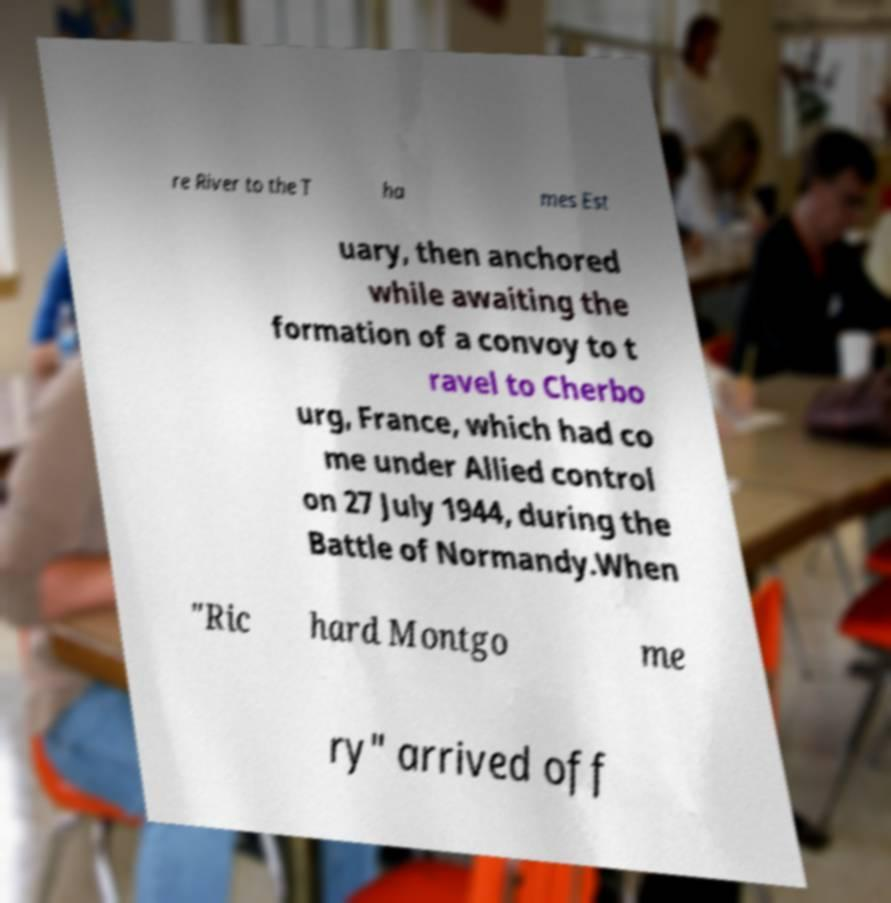Can you accurately transcribe the text from the provided image for me? re River to the T ha mes Est uary, then anchored while awaiting the formation of a convoy to t ravel to Cherbo urg, France, which had co me under Allied control on 27 July 1944, during the Battle of Normandy.When "Ric hard Montgo me ry" arrived off 